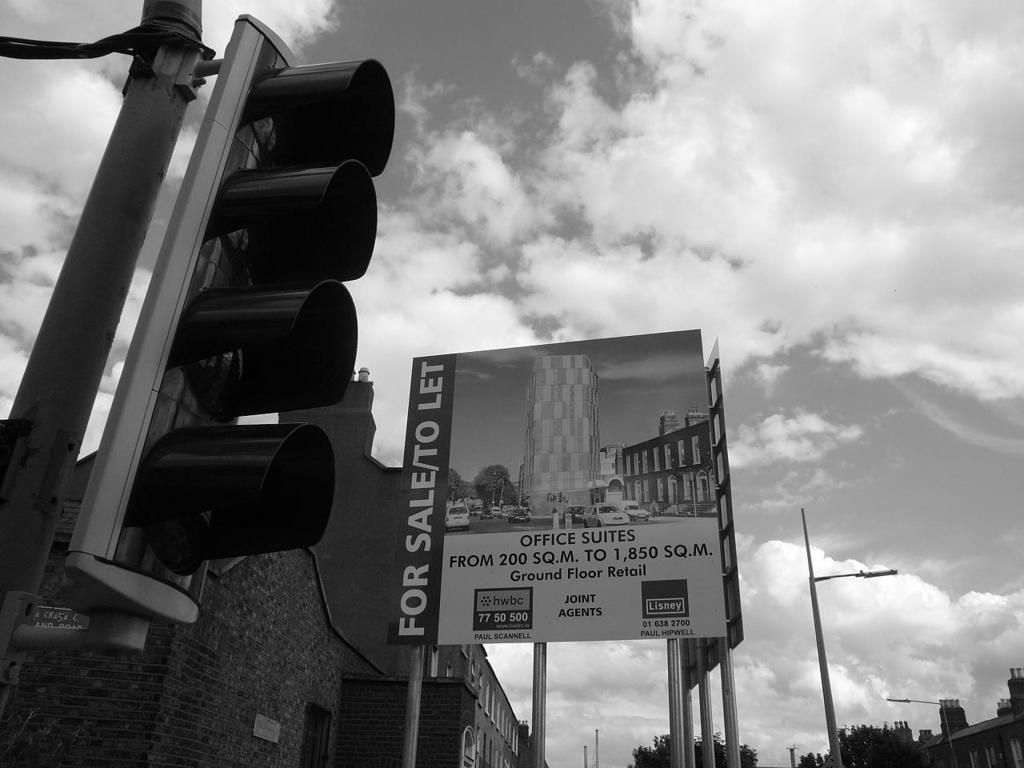<image>
Write a terse but informative summary of the picture. A black and white photo showing a sign for sale 